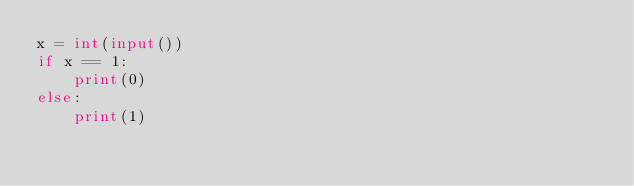<code> <loc_0><loc_0><loc_500><loc_500><_Python_>x = int(input())
if x == 1:
    print(0)
else:
    print(1)</code> 